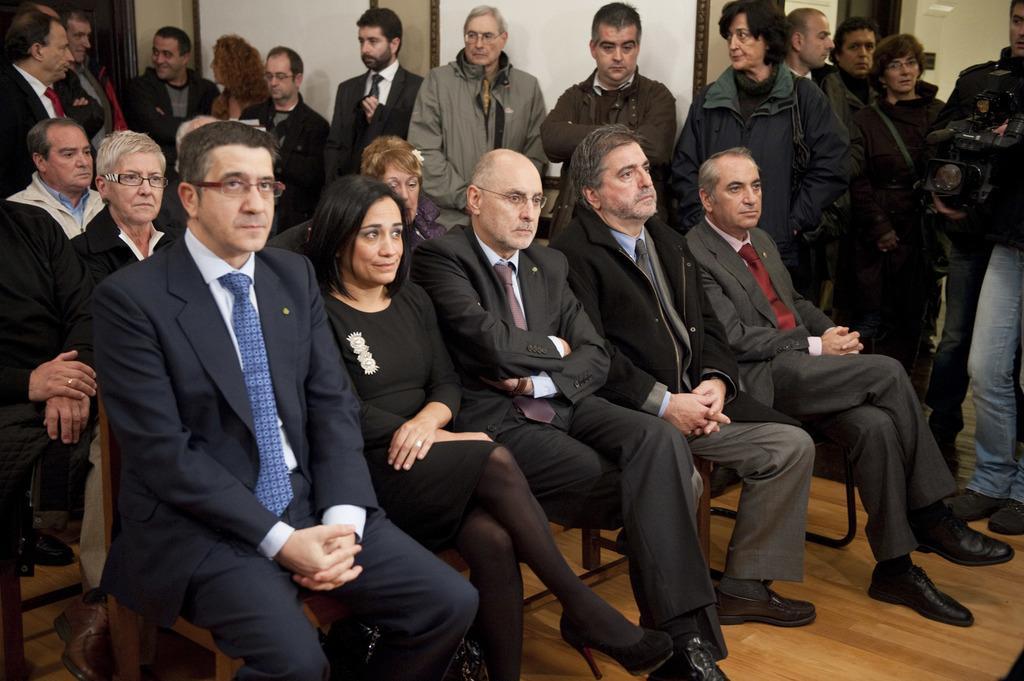Could you give a brief overview of what you see in this image? In this image I can see few people are sitting and few people are standing. Everyone are wearing suits and looking at the right side. On the right side I can see a man standing and holding a camera in the hands. In the background, I can see a wall. 